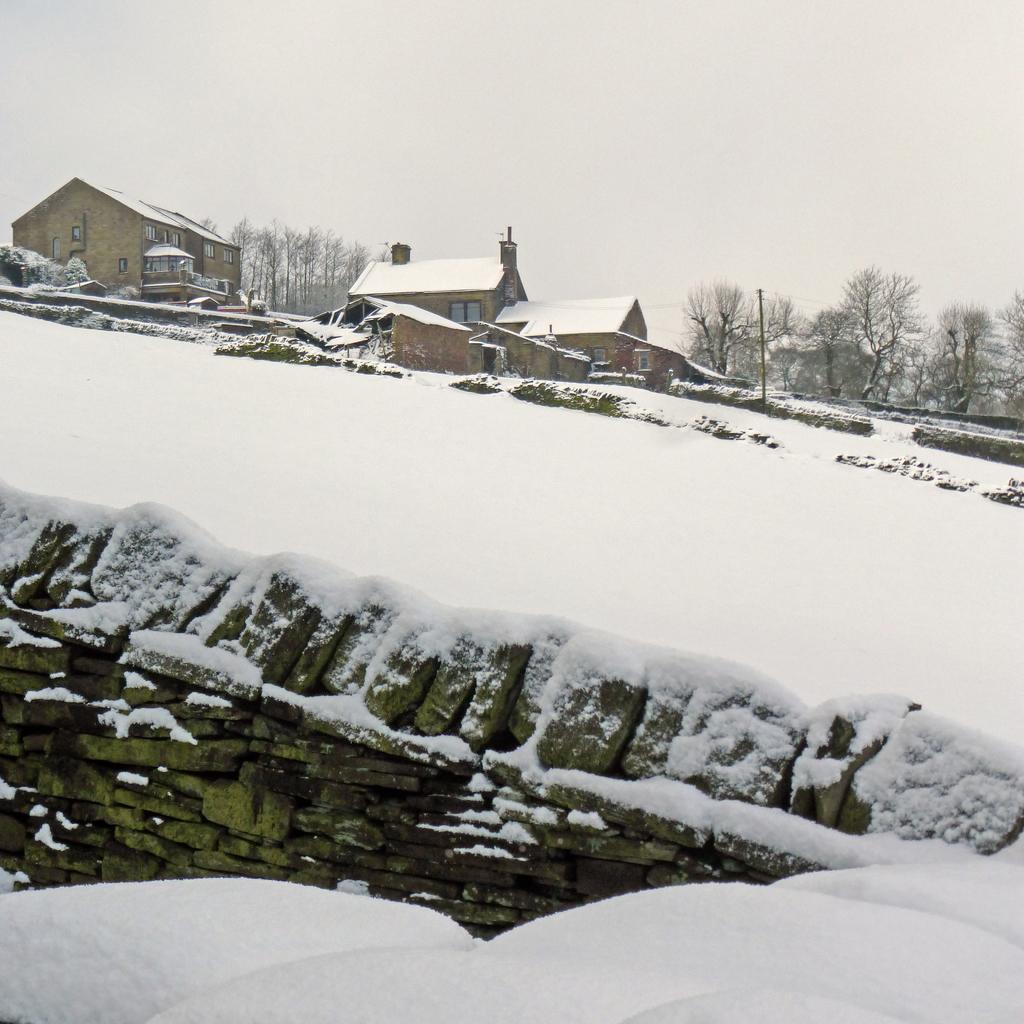Can you describe this image briefly? At the bottom there is a wall covered with the snow. In the background there are few houses and trees. At the top of the image I can see the sky. 